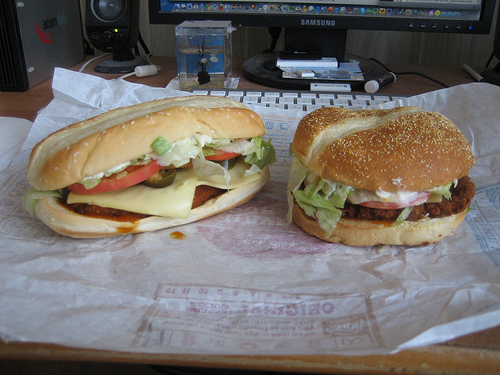Please provide a short description for this region: [0.57, 0.44, 0.68, 0.6]. A fresh piece of lettuce on top of a hamburger, adding a crisp, green touch to the meal. 